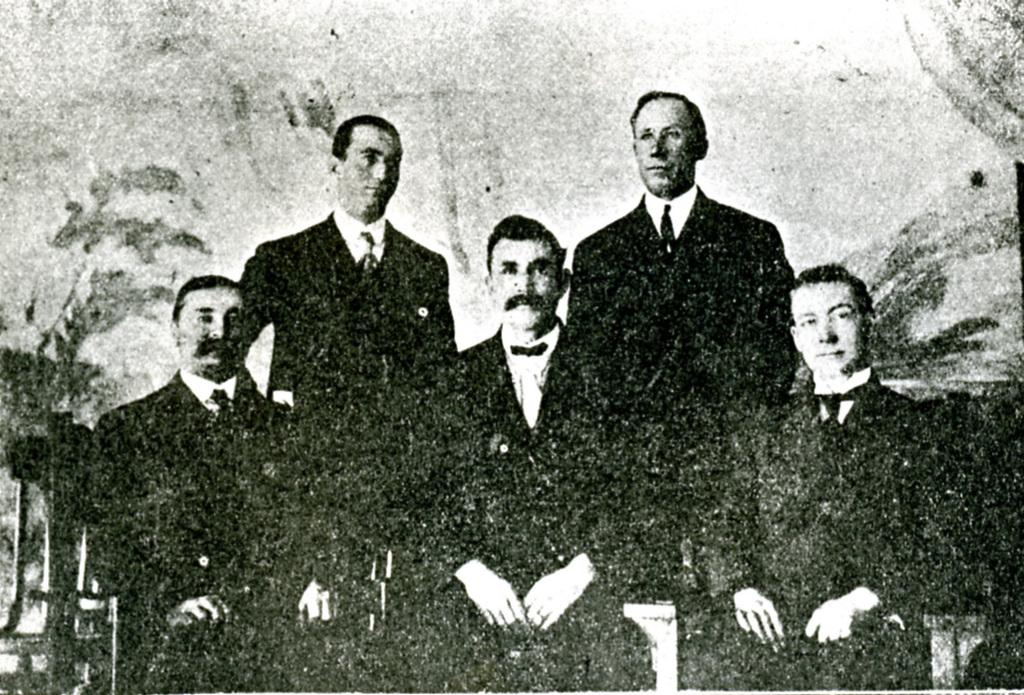How many people are sitting in the image? There are three persons sitting on chairs in the image. How many people are standing in the image? There are two persons standing in the image. Can you describe the positions of the people in the image? Three people are sitting on chairs, and two people are standing. What can be said about the background of the image? The background of the image is not clear. What type of cake is being served on the leg of the person in the image? There is no cake or leg visible in the image; it only shows people sitting and standing. 